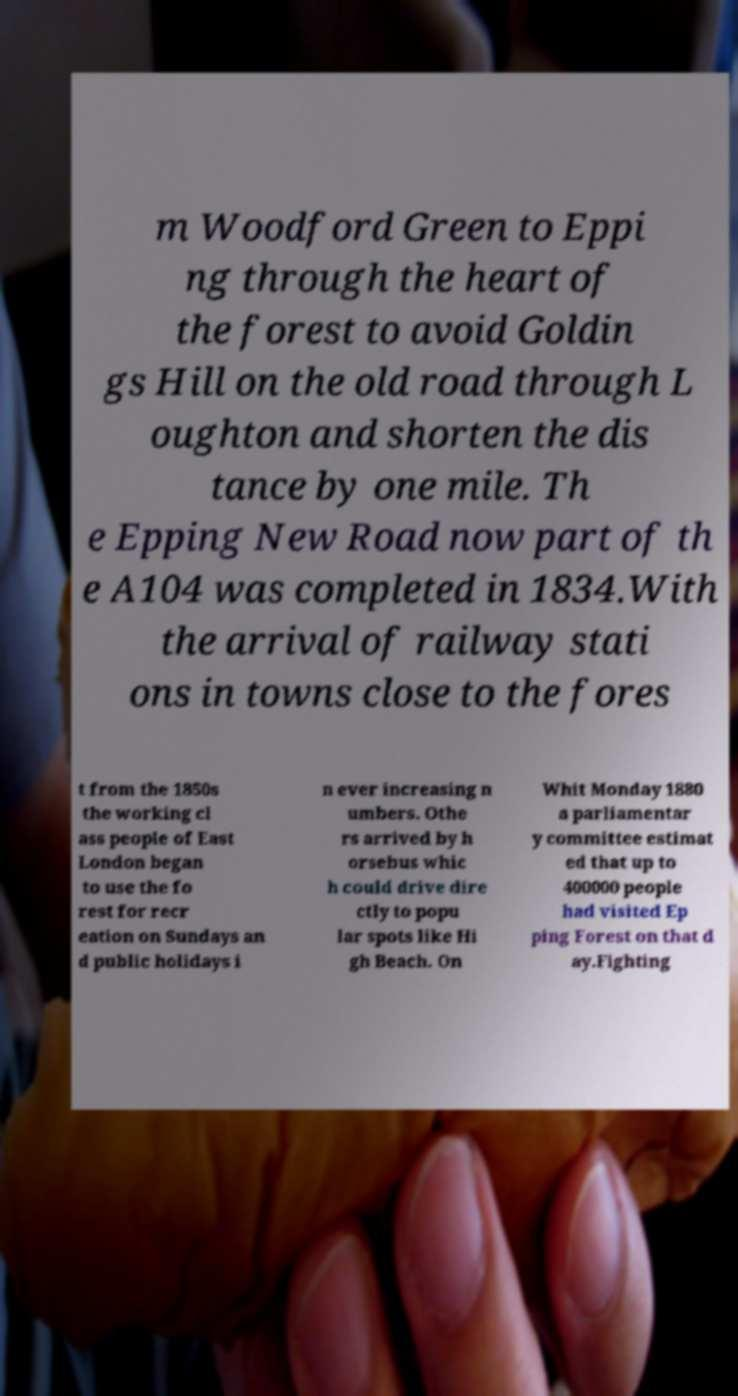Can you read and provide the text displayed in the image?This photo seems to have some interesting text. Can you extract and type it out for me? m Woodford Green to Eppi ng through the heart of the forest to avoid Goldin gs Hill on the old road through L oughton and shorten the dis tance by one mile. Th e Epping New Road now part of th e A104 was completed in 1834.With the arrival of railway stati ons in towns close to the fores t from the 1850s the working cl ass people of East London began to use the fo rest for recr eation on Sundays an d public holidays i n ever increasing n umbers. Othe rs arrived by h orsebus whic h could drive dire ctly to popu lar spots like Hi gh Beach. On Whit Monday 1880 a parliamentar y committee estimat ed that up to 400000 people had visited Ep ping Forest on that d ay.Fighting 